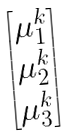<formula> <loc_0><loc_0><loc_500><loc_500>\begin{bmatrix} \mu _ { 1 } ^ { k } \\ \mu _ { 2 } ^ { k } \\ \mu _ { 3 } ^ { k } \end{bmatrix}</formula> 